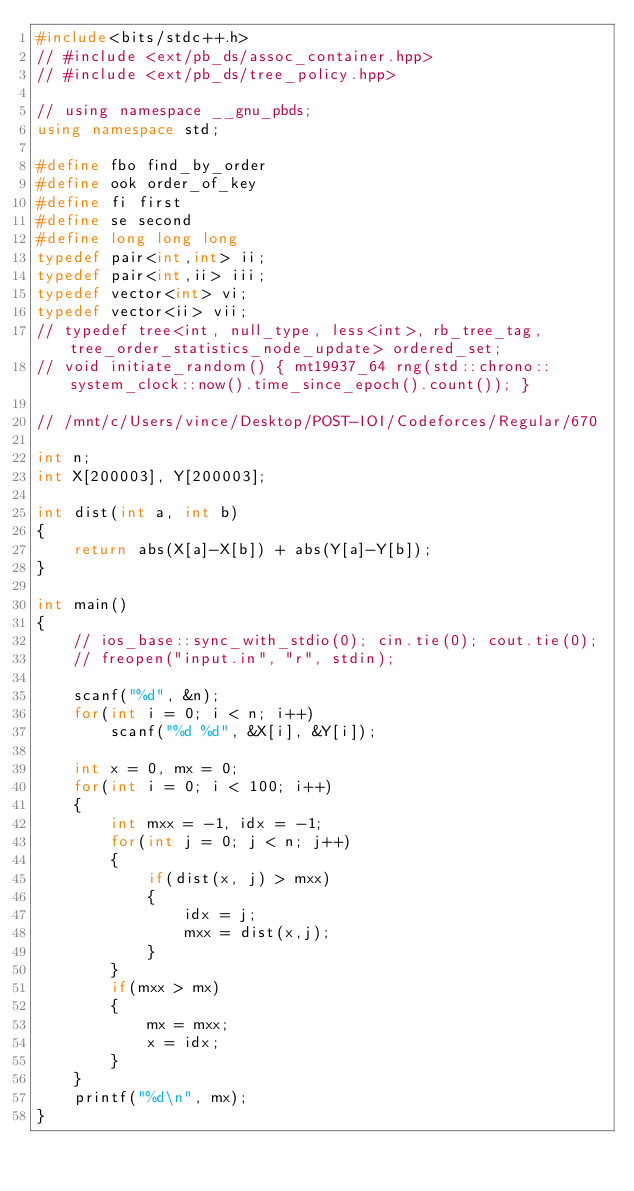<code> <loc_0><loc_0><loc_500><loc_500><_C++_>#include<bits/stdc++.h>
// #include <ext/pb_ds/assoc_container.hpp>
// #include <ext/pb_ds/tree_policy.hpp>

// using namespace __gnu_pbds;
using namespace std;

#define fbo find_by_order
#define ook order_of_key
#define fi first
#define se second
#define long long long
typedef pair<int,int> ii;
typedef pair<int,ii> iii;
typedef vector<int> vi;
typedef vector<ii> vii;
// typedef tree<int, null_type, less<int>, rb_tree_tag, tree_order_statistics_node_update> ordered_set;
// void initiate_random() { mt19937_64 rng(std::chrono::system_clock::now().time_since_epoch().count()); }

// /mnt/c/Users/vince/Desktop/POST-IOI/Codeforces/Regular/670

int n;
int X[200003], Y[200003];

int dist(int a, int b)
{
	return abs(X[a]-X[b]) + abs(Y[a]-Y[b]);
}

int main()
{
	// ios_base::sync_with_stdio(0); cin.tie(0); cout.tie(0);
	// freopen("input.in", "r", stdin);

	scanf("%d", &n);
	for(int i = 0; i < n; i++)
		scanf("%d %d", &X[i], &Y[i]);

	int x = 0, mx = 0;
	for(int i = 0; i < 100; i++)
	{
		int mxx = -1, idx = -1;
		for(int j = 0; j < n; j++)
		{	
			if(dist(x, j) > mxx)
			{
				idx = j;
				mxx = dist(x,j);
			}
		}
		if(mxx > mx)
		{
			mx = mxx;
			x = idx;
		}
	}
	printf("%d\n", mx);
}</code> 